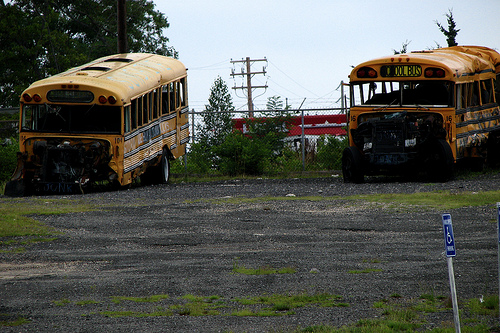Is the bus on the right of the image? Yes, the bus is positioned on the right side of the image, next to another bus on its left. 